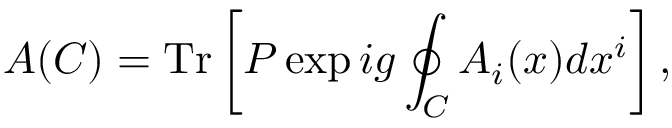<formula> <loc_0><loc_0><loc_500><loc_500>A ( C ) = T r \left [ P \exp i g \oint _ { C } A _ { i } ( x ) d x ^ { i } \right ] ,</formula> 